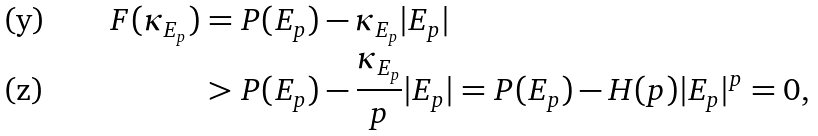<formula> <loc_0><loc_0><loc_500><loc_500>F ( \kappa _ { E _ { p } } ) & = P ( E _ { p } ) - \kappa _ { E _ { p } } | E _ { p } | \\ & > P ( E _ { p } ) - \frac { \kappa _ { E _ { p } } } { p } | E _ { p } | = P ( E _ { p } ) - H ( p ) | E _ { p } | ^ { p } = 0 ,</formula> 